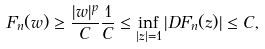<formula> <loc_0><loc_0><loc_500><loc_500>F _ { n } ( w ) \geq \frac { | w | ^ { p } } { C } \frac { 1 } { C } \leq \inf _ { | z | = 1 } | D F _ { n } ( z ) | \leq C ,</formula> 